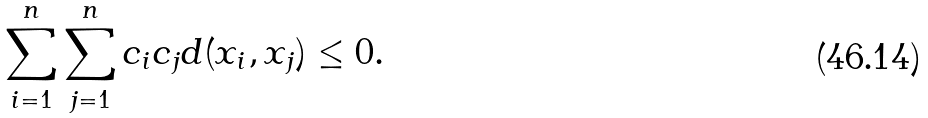Convert formula to latex. <formula><loc_0><loc_0><loc_500><loc_500>\sum _ { i = 1 } ^ { n } \sum _ { j = 1 } ^ { n } c _ { i } c _ { j } d ( x _ { i } , x _ { j } ) \leq 0 .</formula> 